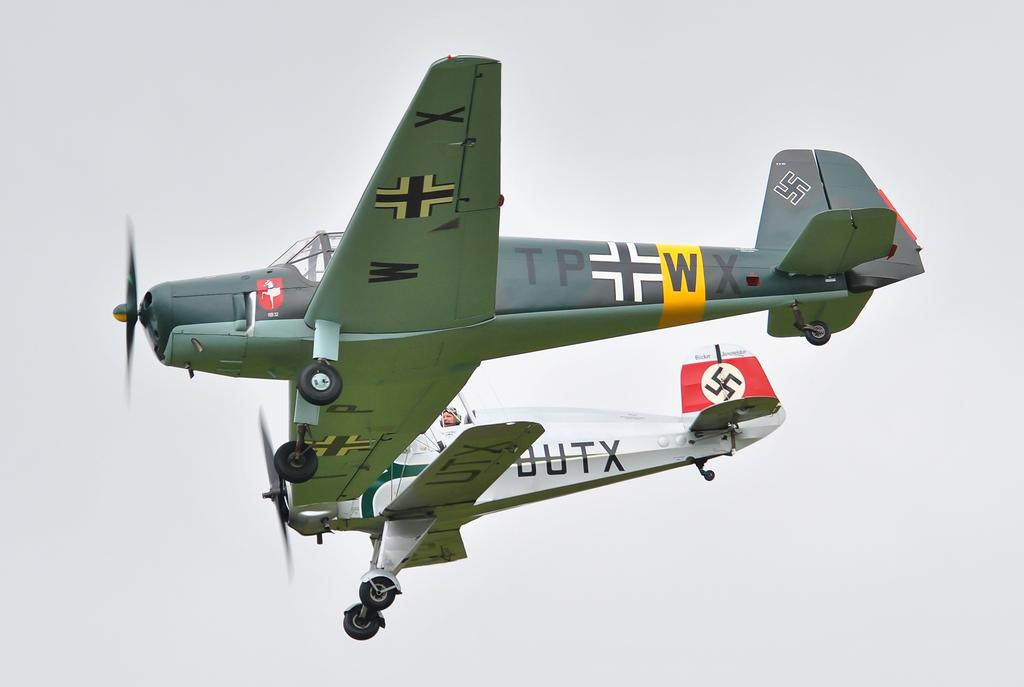Provide a one-sentence caption for the provided image. An airplane with a W and X under the wing is next to an airplane with UTX under the wing. 